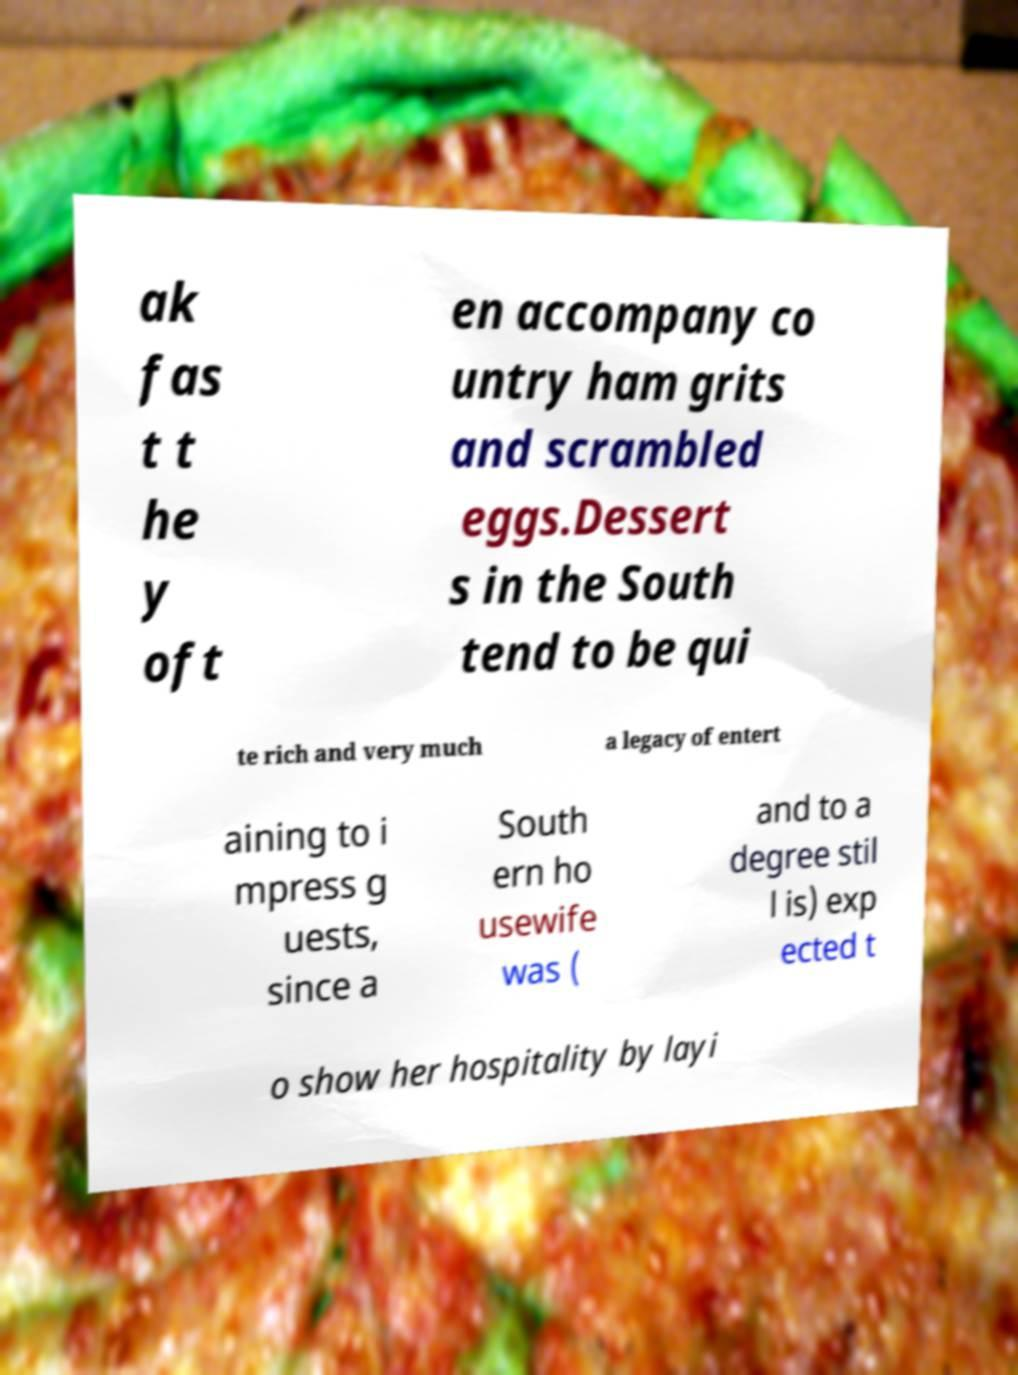Could you extract and type out the text from this image? ak fas t t he y oft en accompany co untry ham grits and scrambled eggs.Dessert s in the South tend to be qui te rich and very much a legacy of entert aining to i mpress g uests, since a South ern ho usewife was ( and to a degree stil l is) exp ected t o show her hospitality by layi 